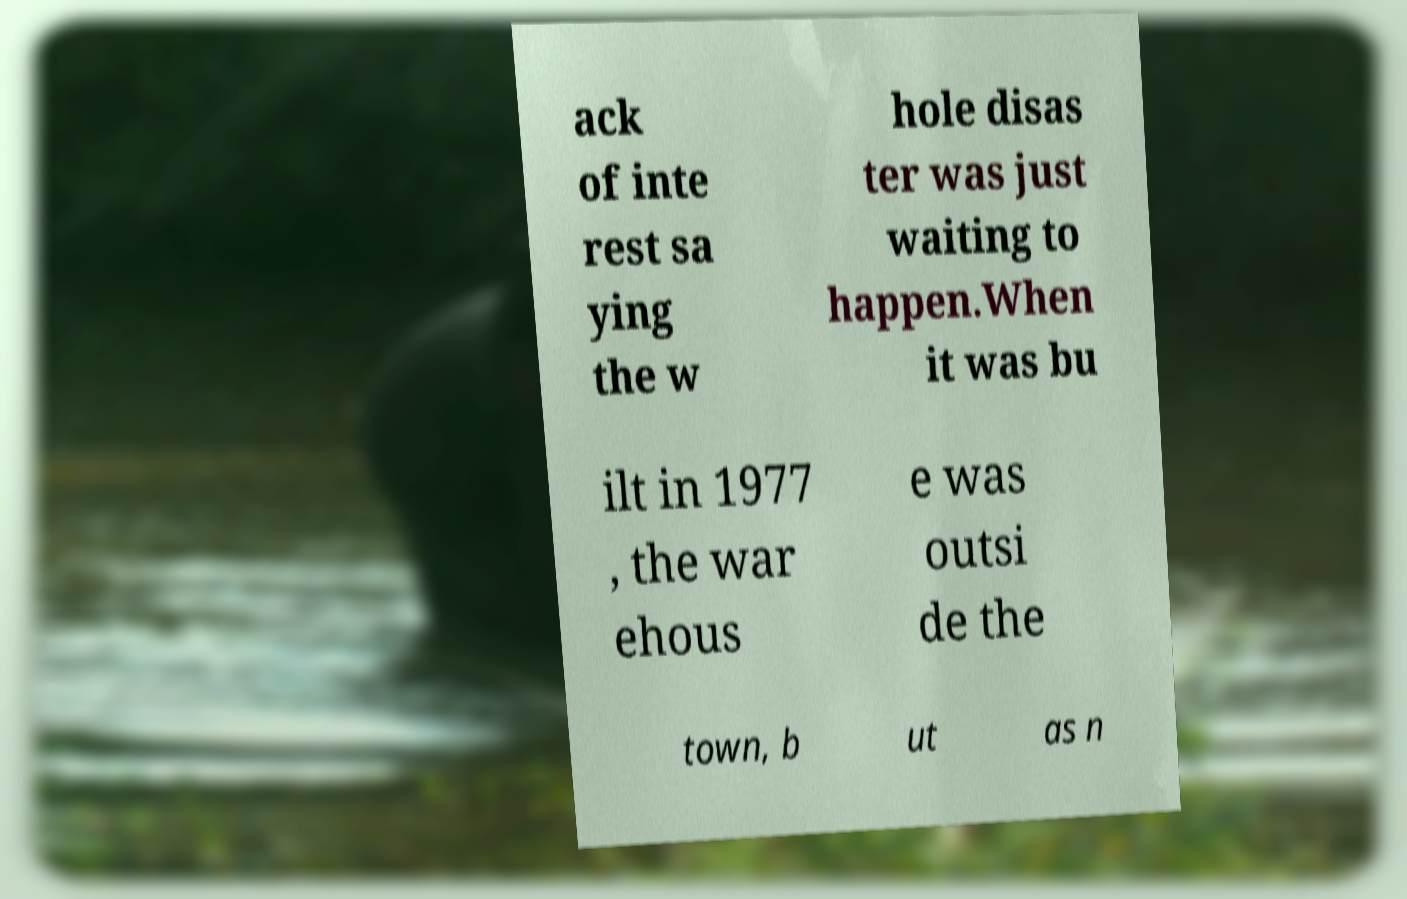Can you accurately transcribe the text from the provided image for me? ack of inte rest sa ying the w hole disas ter was just waiting to happen.When it was bu ilt in 1977 , the war ehous e was outsi de the town, b ut as n 